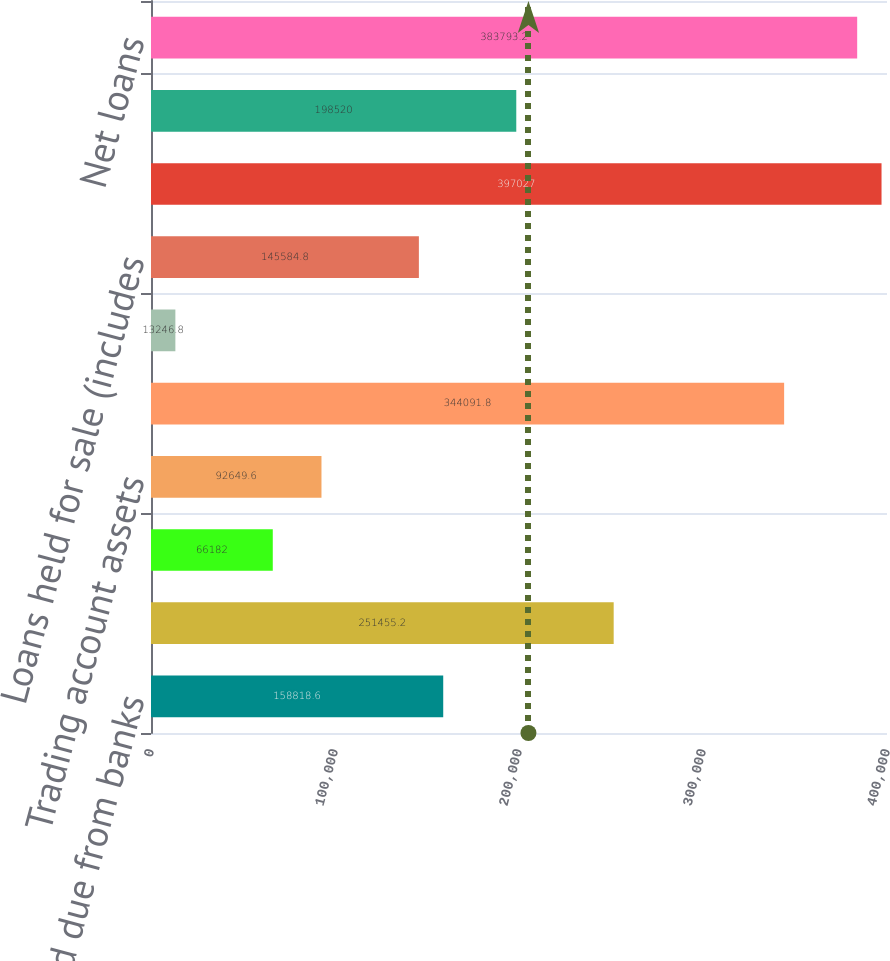Convert chart to OTSL. <chart><loc_0><loc_0><loc_500><loc_500><bar_chart><fcel>Cash and due from banks<fcel>Interest-bearing deposits in<fcel>Federal funds sold and<fcel>Trading account assets<fcel>Securities available for sale<fcel>Securities held to maturity<fcel>Loans held for sale (includes<fcel>Loans net of unearned income<fcel>Allowance for loan losses<fcel>Net loans<nl><fcel>158819<fcel>251455<fcel>66182<fcel>92649.6<fcel>344092<fcel>13246.8<fcel>145585<fcel>397027<fcel>198520<fcel>383793<nl></chart> 